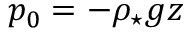Convert formula to latex. <formula><loc_0><loc_0><loc_500><loc_500>p _ { 0 } = - \rho _ { ^ { * } } g z</formula> 